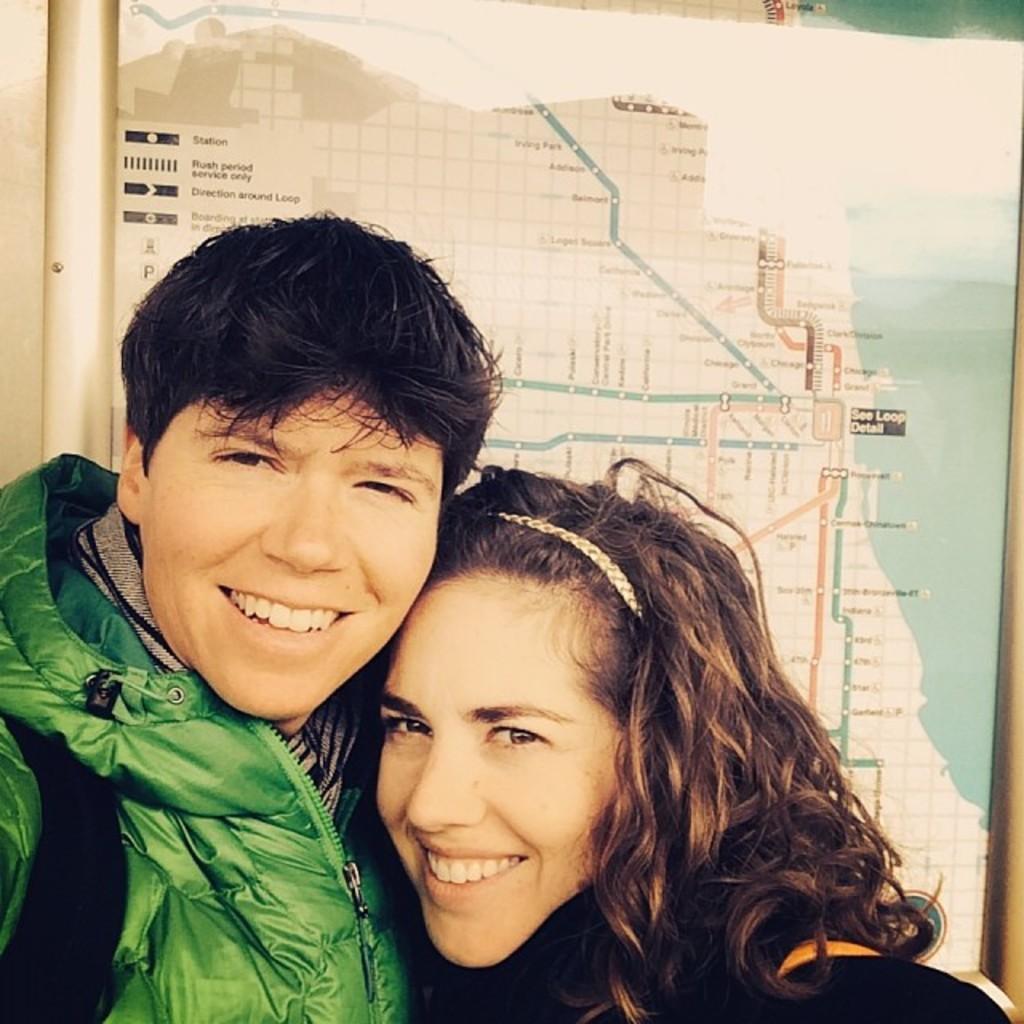How would you summarize this image in a sentence or two? In front of the image there are two persons. They are smiling. Behind them there is a board with a route map on it. 